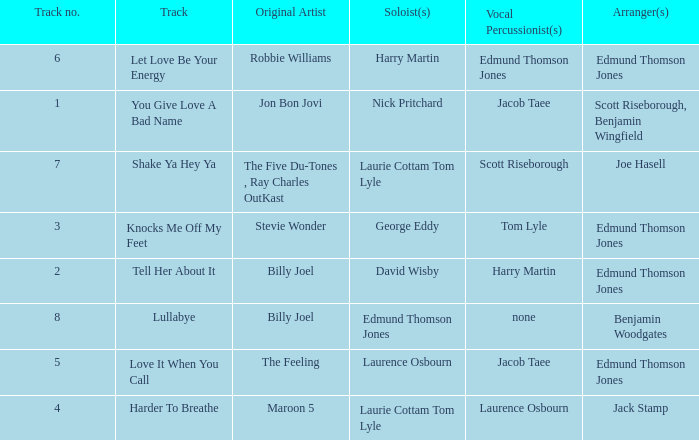Could you parse the entire table? {'header': ['Track no.', 'Track', 'Original Artist', 'Soloist(s)', 'Vocal Percussionist(s)', 'Arranger(s)'], 'rows': [['6', 'Let Love Be Your Energy', 'Robbie Williams', 'Harry Martin', 'Edmund Thomson Jones', 'Edmund Thomson Jones'], ['1', 'You Give Love A Bad Name', 'Jon Bon Jovi', 'Nick Pritchard', 'Jacob Taee', 'Scott Riseborough, Benjamin Wingfield'], ['7', 'Shake Ya Hey Ya', 'The Five Du-Tones , Ray Charles OutKast', 'Laurie Cottam Tom Lyle', 'Scott Riseborough', 'Joe Hasell'], ['3', 'Knocks Me Off My Feet', 'Stevie Wonder', 'George Eddy', 'Tom Lyle', 'Edmund Thomson Jones'], ['2', 'Tell Her About It', 'Billy Joel', 'David Wisby', 'Harry Martin', 'Edmund Thomson Jones'], ['8', 'Lullabye', 'Billy Joel', 'Edmund Thomson Jones', 'none', 'Benjamin Woodgates'], ['5', 'Love It When You Call', 'The Feeling', 'Laurence Osbourn', 'Jacob Taee', 'Edmund Thomson Jones'], ['4', 'Harder To Breathe', 'Maroon 5', 'Laurie Cottam Tom Lyle', 'Laurence Osbourn', 'Jack Stamp']]} How many tracks have the title let love be your energy? 1.0. 